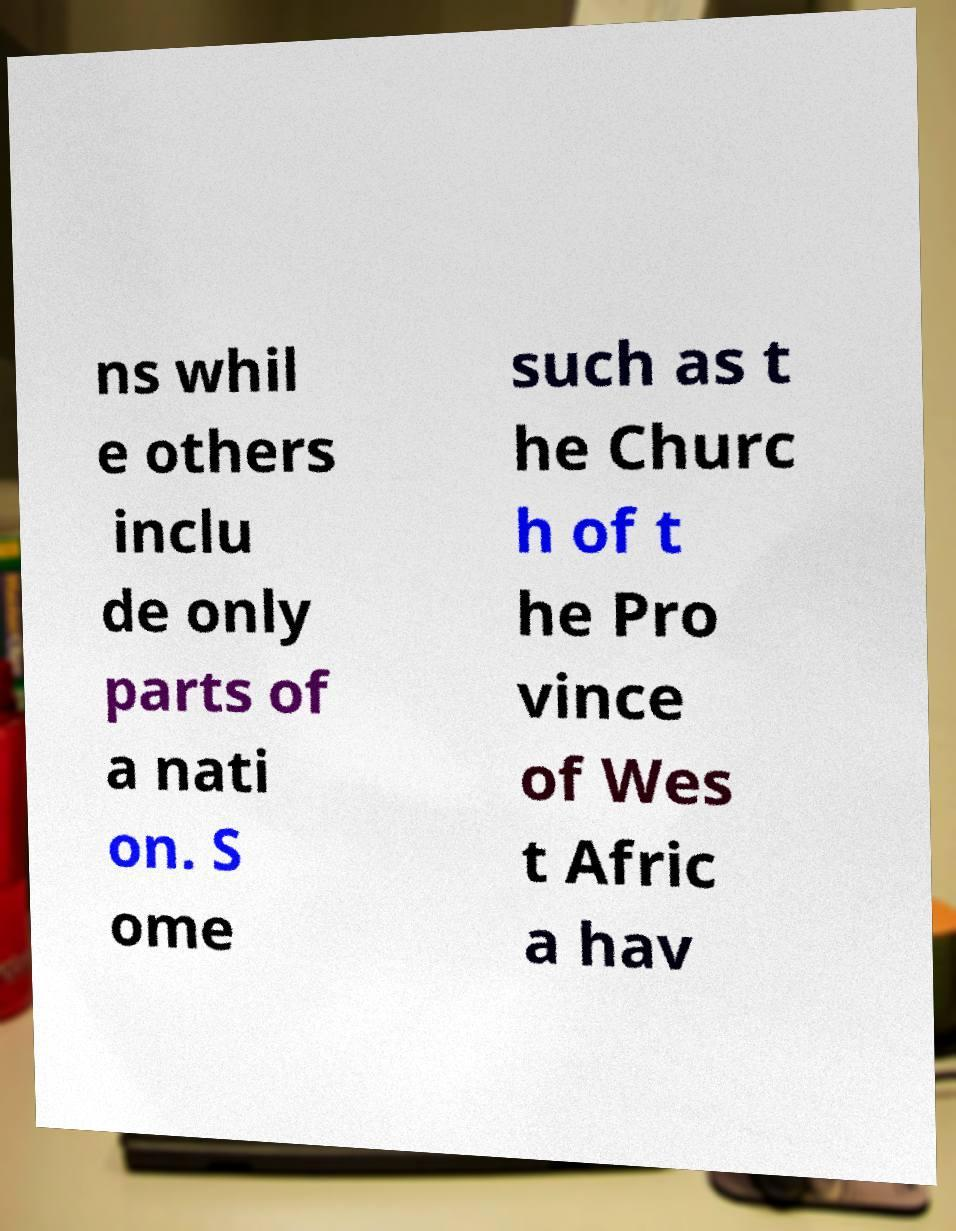Please identify and transcribe the text found in this image. ns whil e others inclu de only parts of a nati on. S ome such as t he Churc h of t he Pro vince of Wes t Afric a hav 